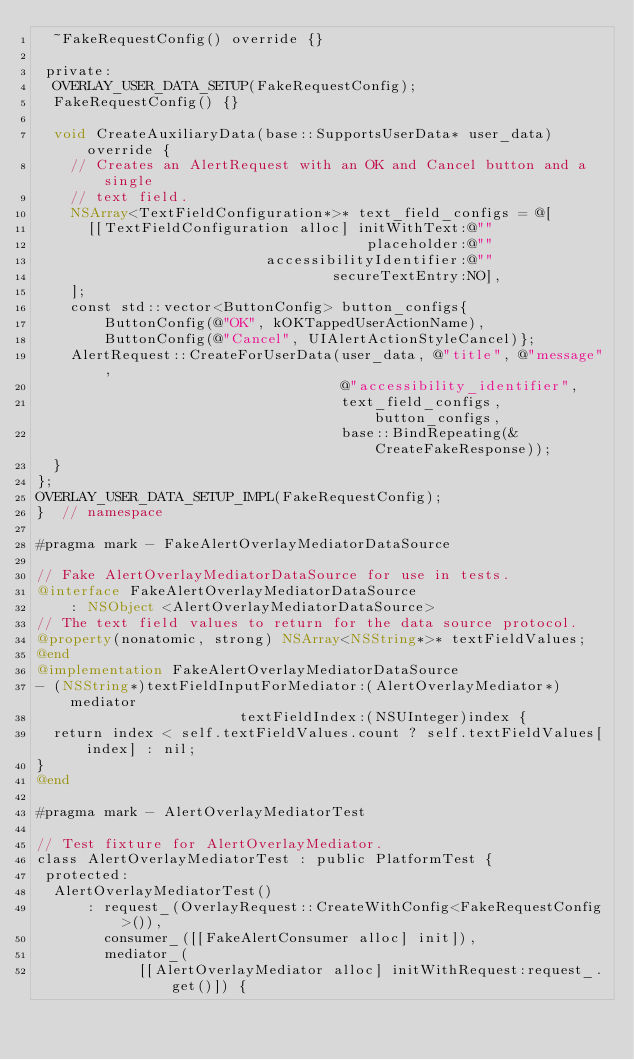Convert code to text. <code><loc_0><loc_0><loc_500><loc_500><_ObjectiveC_>  ~FakeRequestConfig() override {}

 private:
  OVERLAY_USER_DATA_SETUP(FakeRequestConfig);
  FakeRequestConfig() {}

  void CreateAuxiliaryData(base::SupportsUserData* user_data) override {
    // Creates an AlertRequest with an OK and Cancel button and a single
    // text field.
    NSArray<TextFieldConfiguration*>* text_field_configs = @[
      [[TextFieldConfiguration alloc] initWithText:@""
                                       placeholder:@""
                           accessibilityIdentifier:@""
                                   secureTextEntry:NO],
    ];
    const std::vector<ButtonConfig> button_configs{
        ButtonConfig(@"OK", kOKTappedUserActionName),
        ButtonConfig(@"Cancel", UIAlertActionStyleCancel)};
    AlertRequest::CreateForUserData(user_data, @"title", @"message",
                                    @"accessibility_identifier",
                                    text_field_configs, button_configs,
                                    base::BindRepeating(&CreateFakeResponse));
  }
};
OVERLAY_USER_DATA_SETUP_IMPL(FakeRequestConfig);
}  // namespace

#pragma mark - FakeAlertOverlayMediatorDataSource

// Fake AlertOverlayMediatorDataSource for use in tests.
@interface FakeAlertOverlayMediatorDataSource
    : NSObject <AlertOverlayMediatorDataSource>
// The text field values to return for the data source protocol.
@property(nonatomic, strong) NSArray<NSString*>* textFieldValues;
@end
@implementation FakeAlertOverlayMediatorDataSource
- (NSString*)textFieldInputForMediator:(AlertOverlayMediator*)mediator
                        textFieldIndex:(NSUInteger)index {
  return index < self.textFieldValues.count ? self.textFieldValues[index] : nil;
}
@end

#pragma mark - AlertOverlayMediatorTest

// Test fixture for AlertOverlayMediator.
class AlertOverlayMediatorTest : public PlatformTest {
 protected:
  AlertOverlayMediatorTest()
      : request_(OverlayRequest::CreateWithConfig<FakeRequestConfig>()),
        consumer_([[FakeAlertConsumer alloc] init]),
        mediator_(
            [[AlertOverlayMediator alloc] initWithRequest:request_.get()]) {</code> 